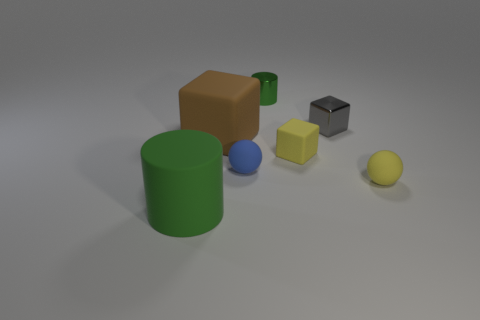Add 1 small spheres. How many objects exist? 8 Subtract all spheres. How many objects are left? 5 Add 4 small blue balls. How many small blue balls are left? 5 Add 5 tiny brown things. How many tiny brown things exist? 5 Subtract 0 brown cylinders. How many objects are left? 7 Subtract all things. Subtract all gray shiny cylinders. How many objects are left? 0 